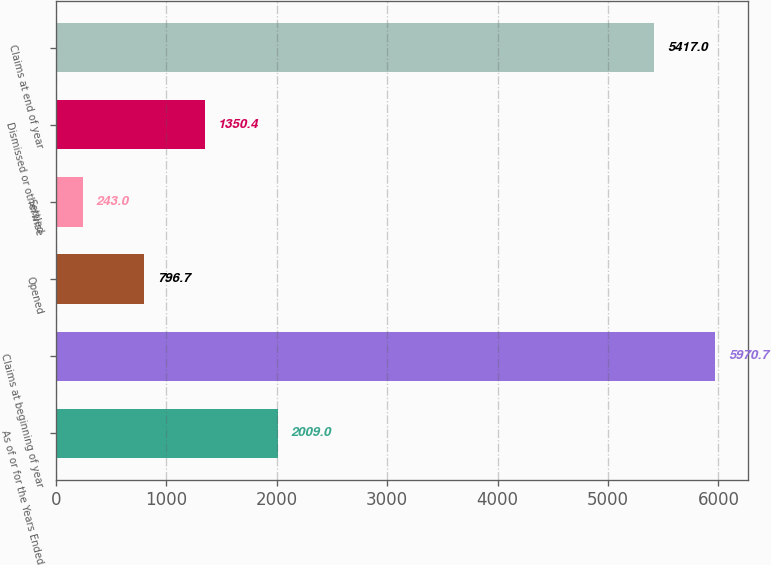<chart> <loc_0><loc_0><loc_500><loc_500><bar_chart><fcel>As of or for the Years Ended<fcel>Claims at beginning of year<fcel>Opened<fcel>Settled<fcel>Dismissed or otherwise<fcel>Claims at end of year<nl><fcel>2009<fcel>5970.7<fcel>796.7<fcel>243<fcel>1350.4<fcel>5417<nl></chart> 